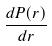Convert formula to latex. <formula><loc_0><loc_0><loc_500><loc_500>\frac { d P ( r ) } { d r }</formula> 